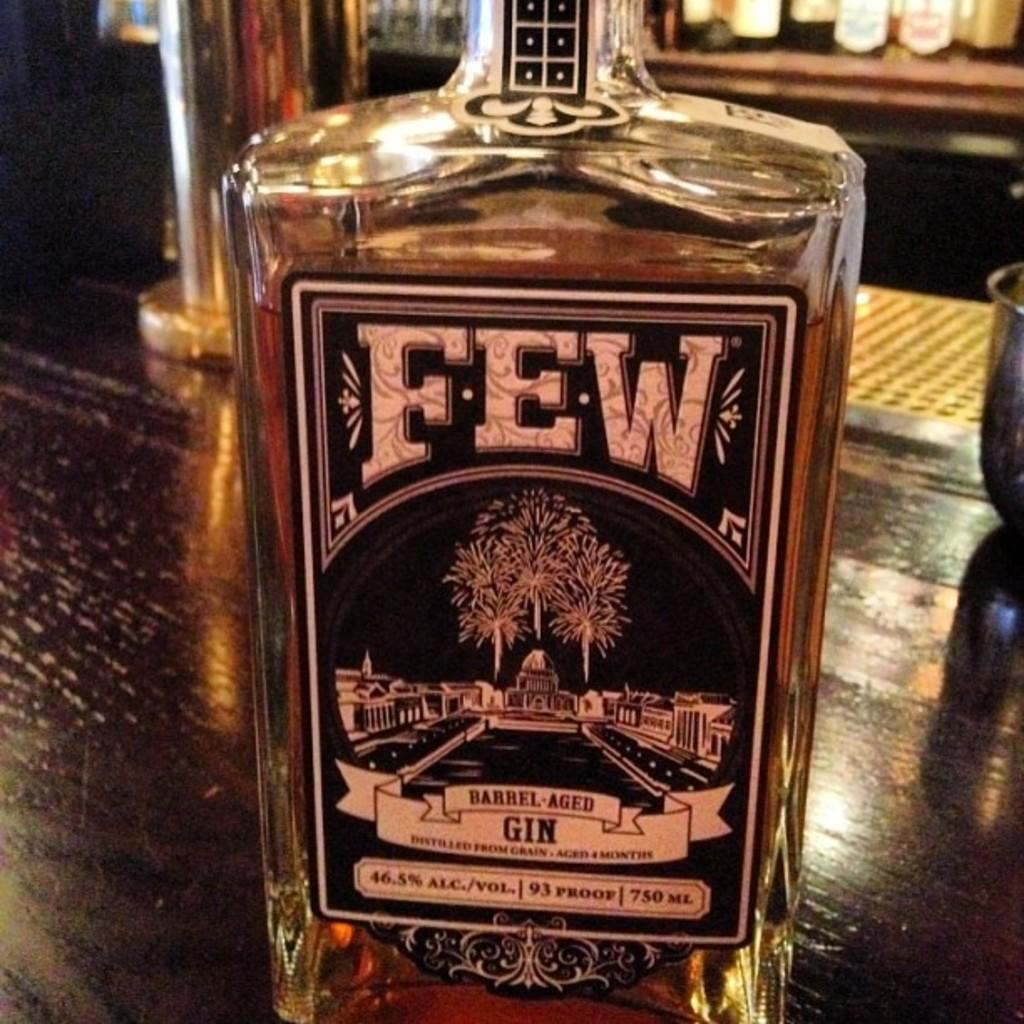<image>
Render a clear and concise summary of the photo. A bottle of Few Barrel Aged gin on a wooden bar counter. 